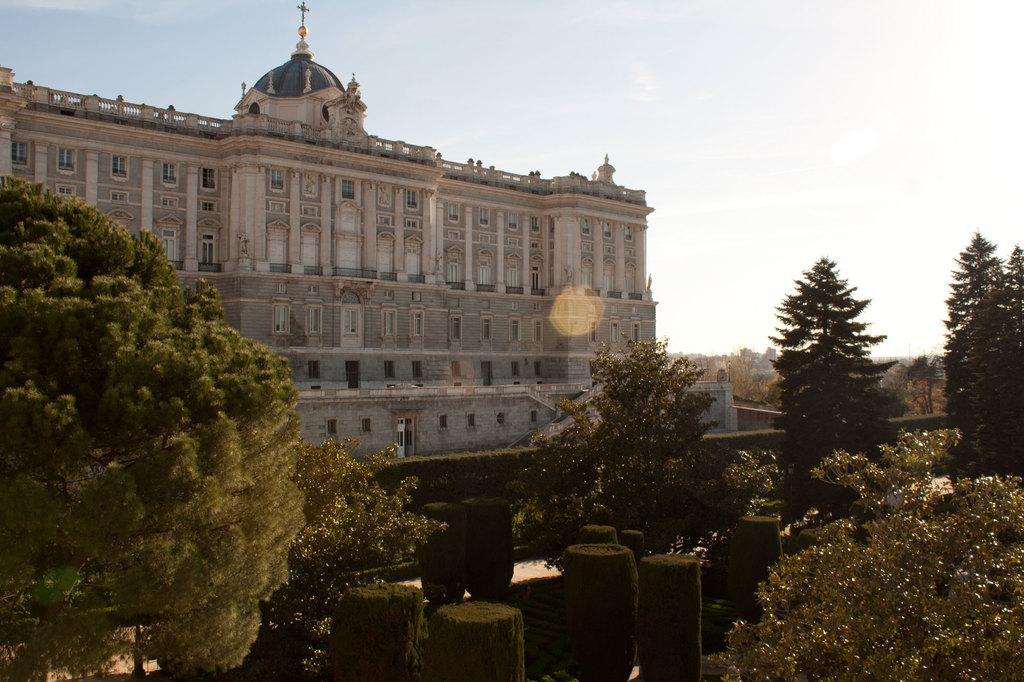What type of structure is present in the image? There is a building in the image. What feature can be seen on the building? The building has windows. What type of vegetation is visible in the image? There are trees and plants in the image. What part of the natural environment is visible in the image? The ground and the sky are visible in the image. What song is being sung by the maid in the image? There is no maid or song present in the image. How does the roll move around in the image? There is no roll present in the image. 